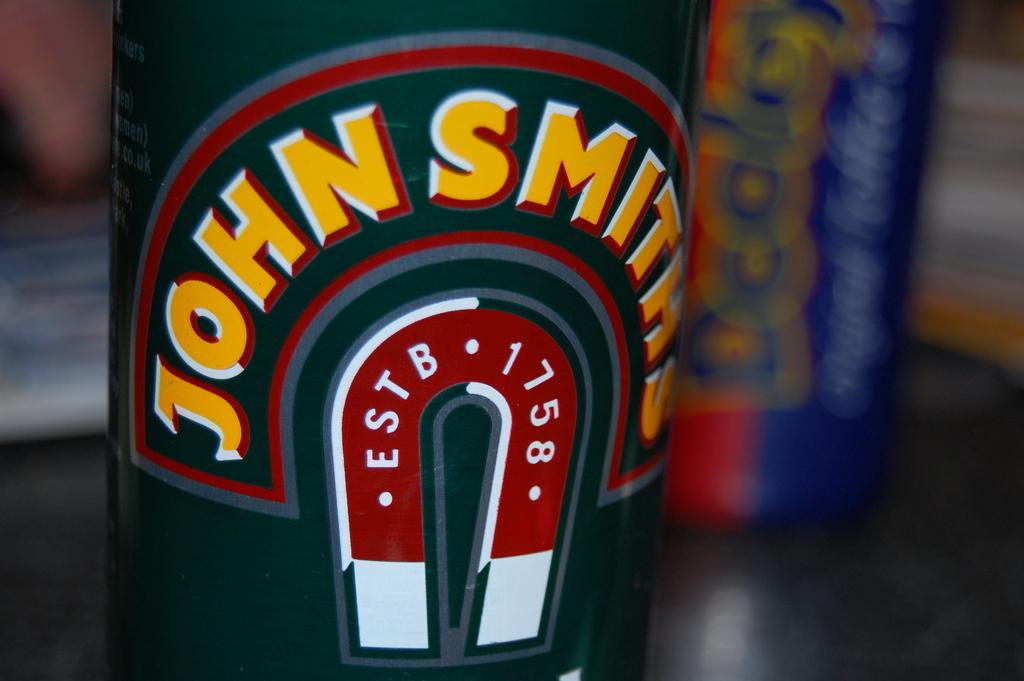<image>
Share a concise interpretation of the image provided. Close up of John Smith which was estb in 1758 